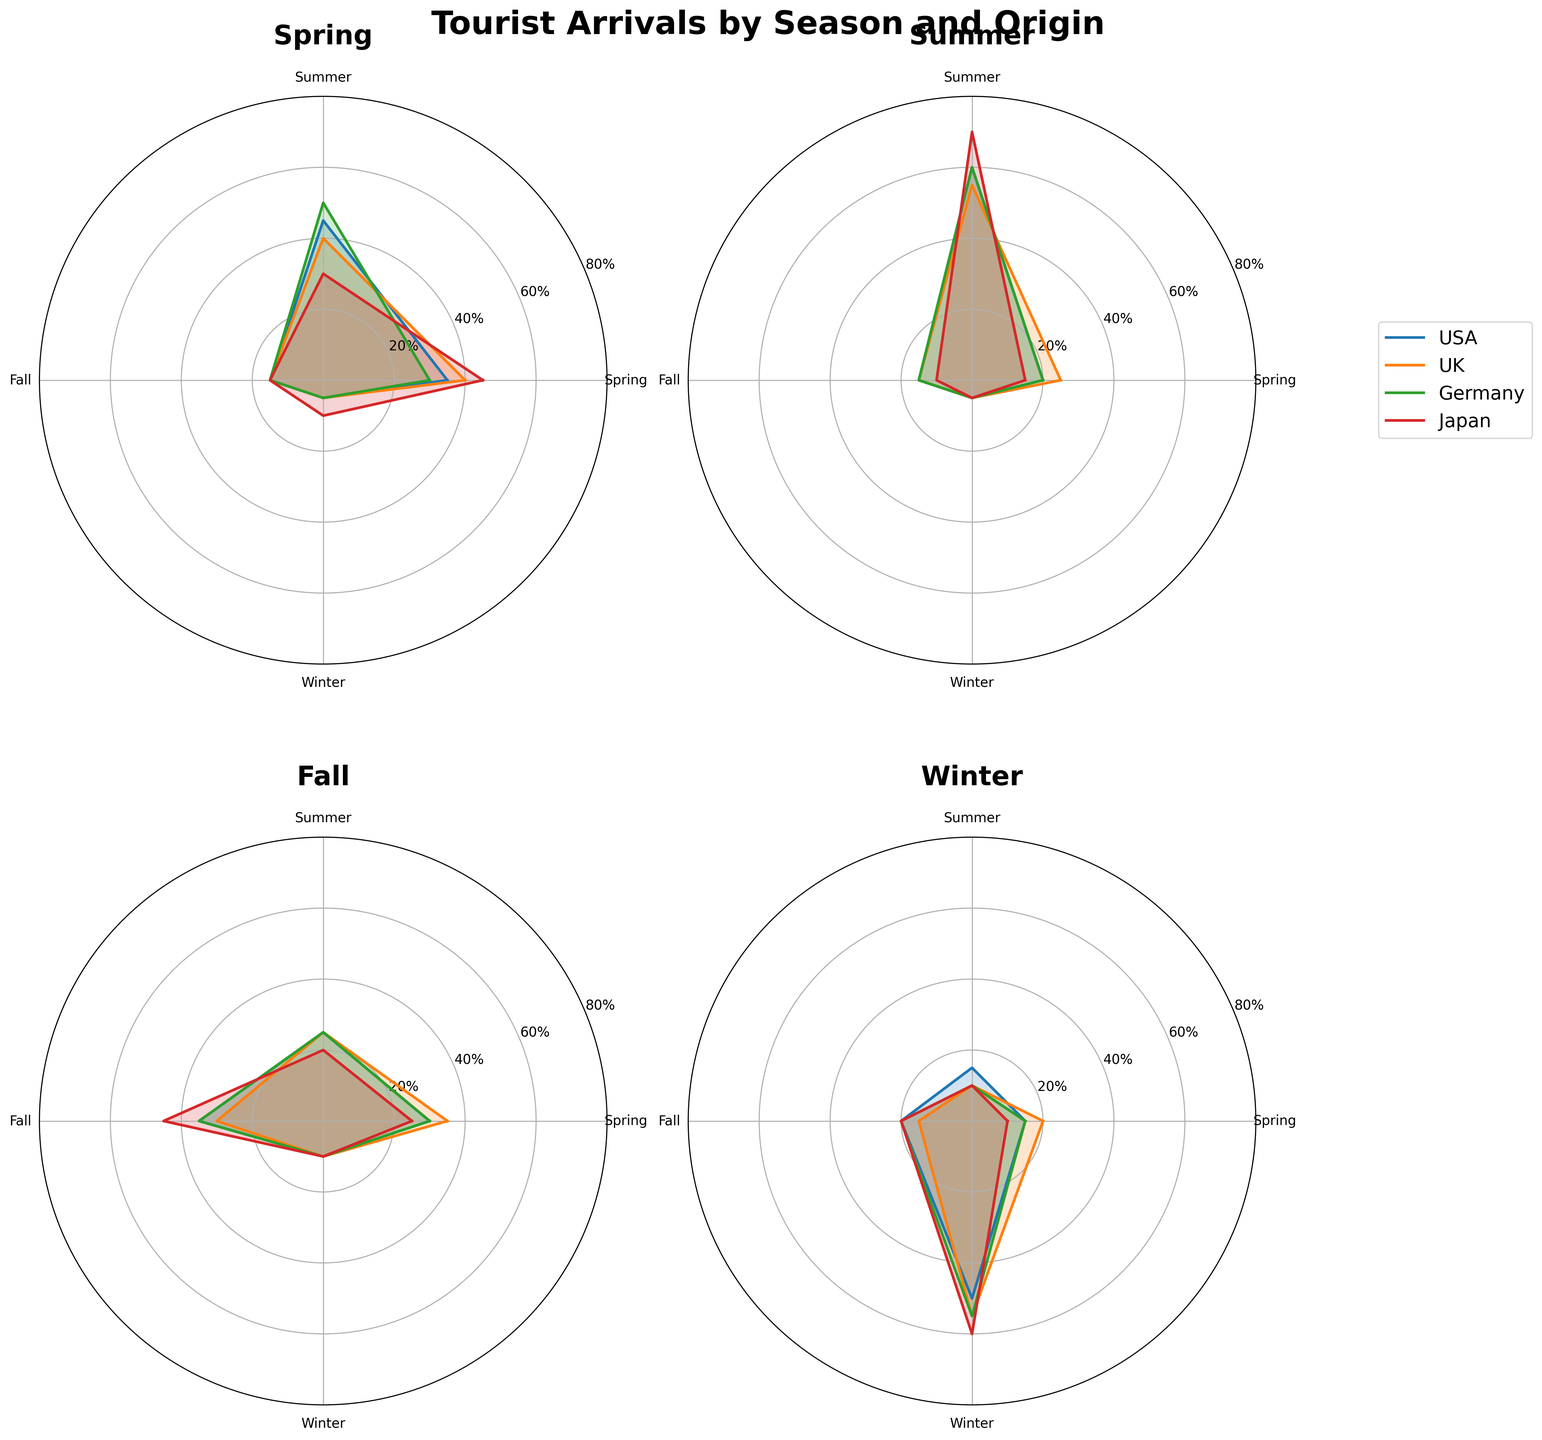What are the seasons displayed in the figure? The subplot titles in the figure indicate the four seasons of tourist arrivals.
Answer: Spring, Summer, Fall, Winter Which country has the highest proportion of tourists visiting in Winter? The polar chart for Winter shows that the country with the highest proportion of tourists (largest segment) is Japan.
Answer: Japan What is the approximate proportion of tourists from the USA in Summer? Looking at the polar chart for Summer, the segment for the USA is about 60% from the center to the outer ring.
Answer: 60% Which country has the lowest proportion of tourists in Fall? In the polar chart for Fall, Japan's segment is the smallest, indicating the lowest proportion of tourists.
Answer: Japan Compare the proportions of tourists from the UK in Spring and Fall. In Spring, the UK segment is around 40%, while in Fall, it is approximately 30%. Thus, the proportion is higher in Spring.
Answer: Higher in Spring How do the proportions of tourists from Japan differ between Summer and Winter? The chart shows that in Summer, Japan's segment is larger (about 70%) compared to Winter (about 60%). The proportion is higher in Summer.
Answer: Higher in Summer Which country shows the most consistent proportion of tourists across all seasons? The country with the most consistent segment sizes across all charts is Germany. Each segment appears roughly similar across all four seasons.
Answer: Germany What season has the highest variability in the proportion of tourists across different countries? The season with the most variation in segment sizes for different countries is Winter, where Japan's segment is significantly larger than the others.
Answer: Winter In which season do tourists from Germany have the highest proportion of arrivals? The polar chart for Summer shows that tourists from Germany have their largest segment, indicating the highest proportion.
Answer: Summer 